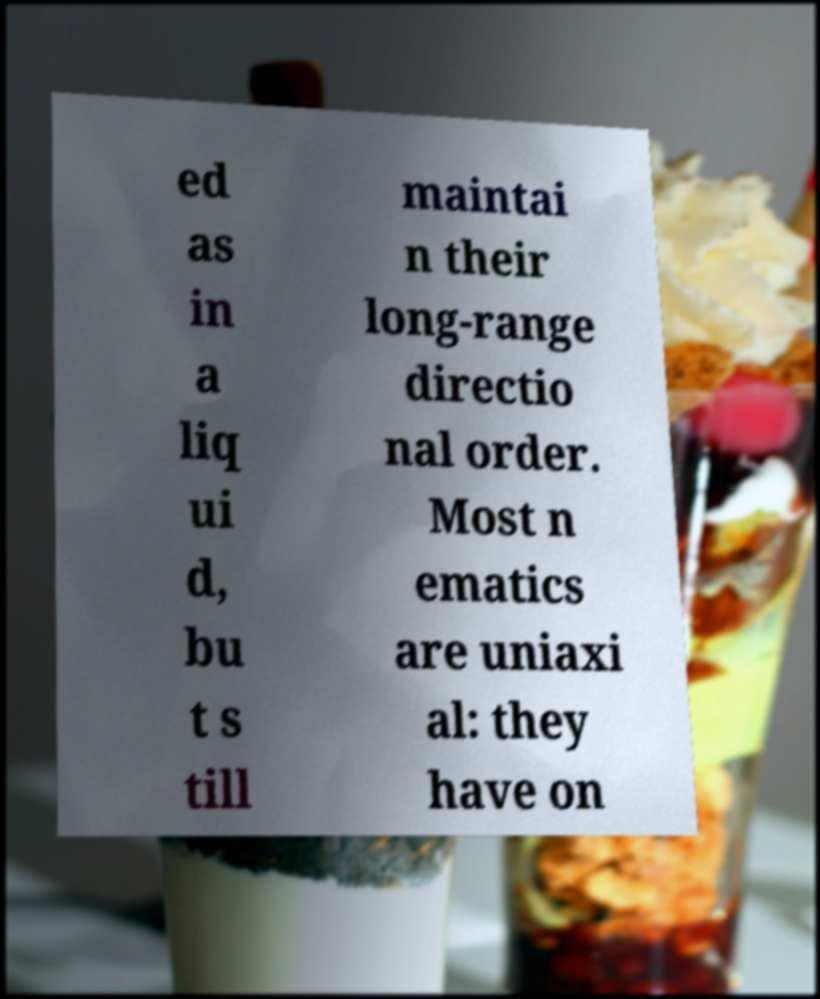Please read and relay the text visible in this image. What does it say? ed as in a liq ui d, bu t s till maintai n their long-range directio nal order. Most n ematics are uniaxi al: they have on 